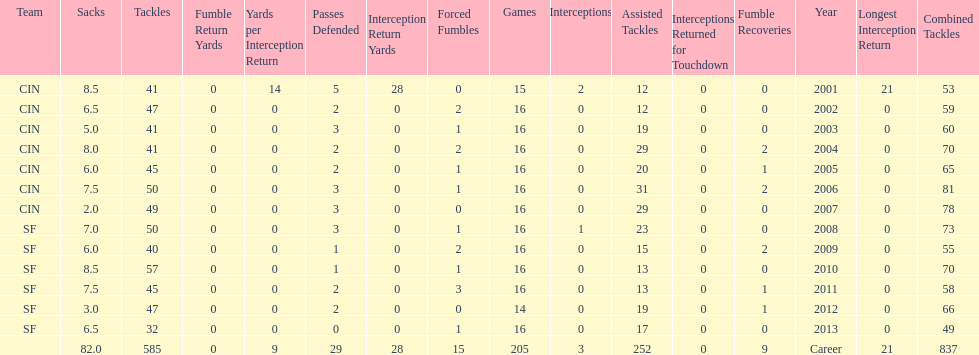What is the total number of sacks smith has made? 82.0. 